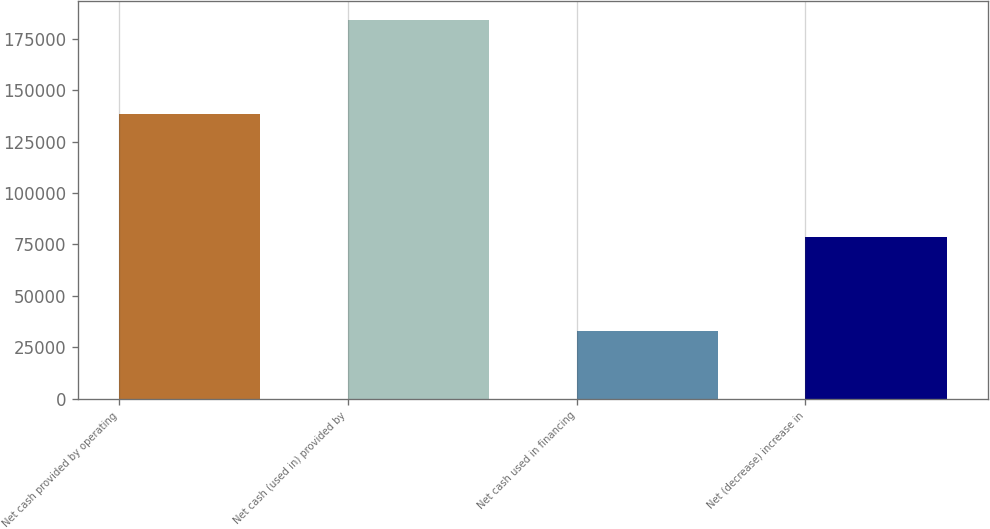<chart> <loc_0><loc_0><loc_500><loc_500><bar_chart><fcel>Net cash provided by operating<fcel>Net cash (used in) provided by<fcel>Net cash used in financing<fcel>Net (decrease) increase in<nl><fcel>138459<fcel>184457<fcel>32797<fcel>78795<nl></chart> 